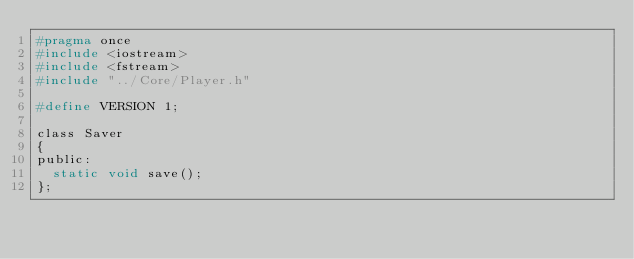<code> <loc_0><loc_0><loc_500><loc_500><_C_>#pragma once
#include <iostream>
#include <fstream>
#include "../Core/Player.h"

#define VERSION 1;

class Saver
{
public:
	static void save();
};

</code> 